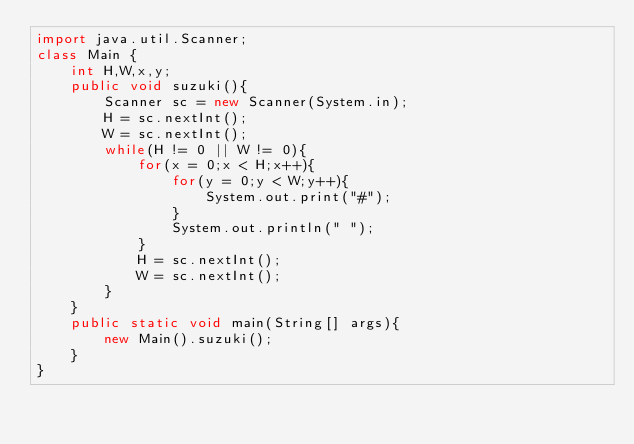<code> <loc_0><loc_0><loc_500><loc_500><_Java_>import java.util.Scanner;
class Main {
	int H,W,x,y;
	public void suzuki(){
		Scanner sc = new Scanner(System.in);
		H = sc.nextInt();
		W = sc.nextInt();
		while(H != 0 || W != 0){
			for(x = 0;x < H;x++){
				for(y = 0;y < W;y++){
					System.out.print("#");
				}
				System.out.println(" ");
			}
			H = sc.nextInt();
			W = sc.nextInt();
		}
	}
	public static void main(String[] args){
		new Main().suzuki();
	}
}</code> 